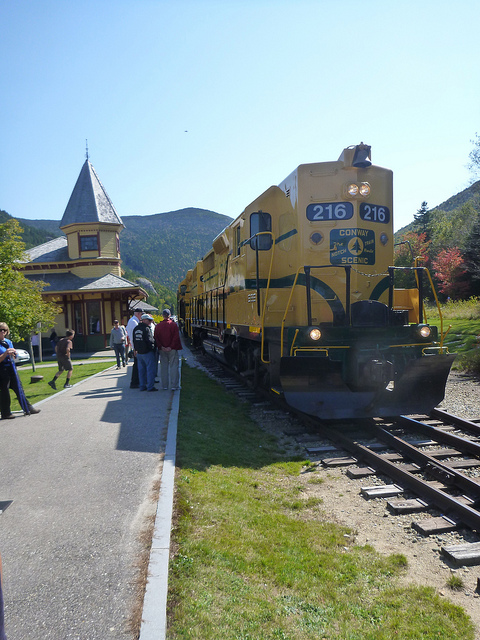Read and extract the text from this image. 216 216 CONWAY 